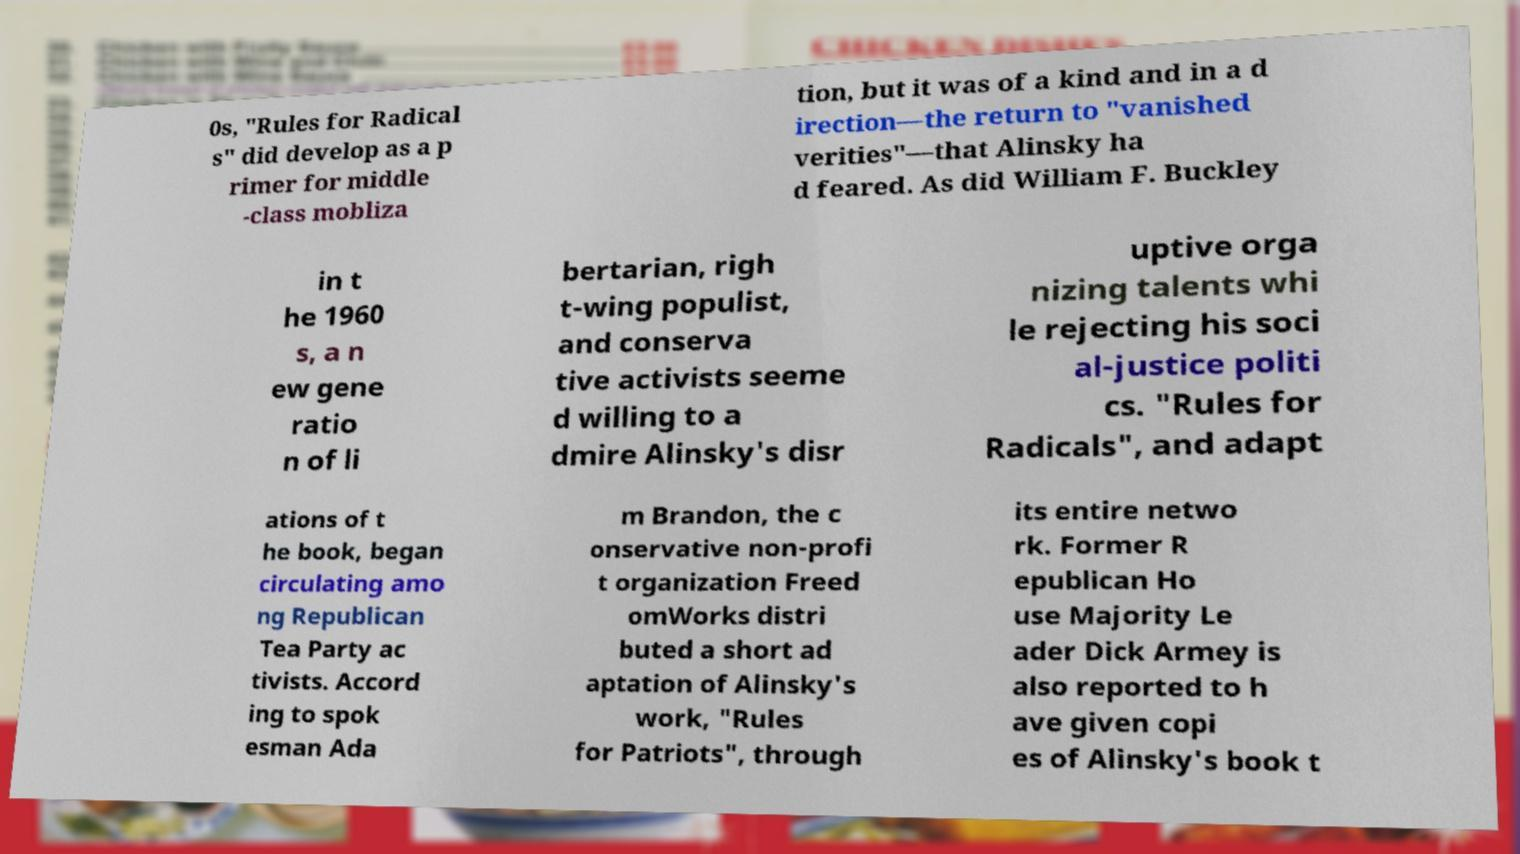What messages or text are displayed in this image? I need them in a readable, typed format. 0s, "Rules for Radical s" did develop as a p rimer for middle -class mobliza tion, but it was of a kind and in a d irection—the return to "vanished verities"—that Alinsky ha d feared. As did William F. Buckley in t he 1960 s, a n ew gene ratio n of li bertarian, righ t-wing populist, and conserva tive activists seeme d willing to a dmire Alinsky's disr uptive orga nizing talents whi le rejecting his soci al-justice politi cs. "Rules for Radicals", and adapt ations of t he book, began circulating amo ng Republican Tea Party ac tivists. Accord ing to spok esman Ada m Brandon, the c onservative non-profi t organization Freed omWorks distri buted a short ad aptation of Alinsky's work, "Rules for Patriots", through its entire netwo rk. Former R epublican Ho use Majority Le ader Dick Armey is also reported to h ave given copi es of Alinsky's book t 